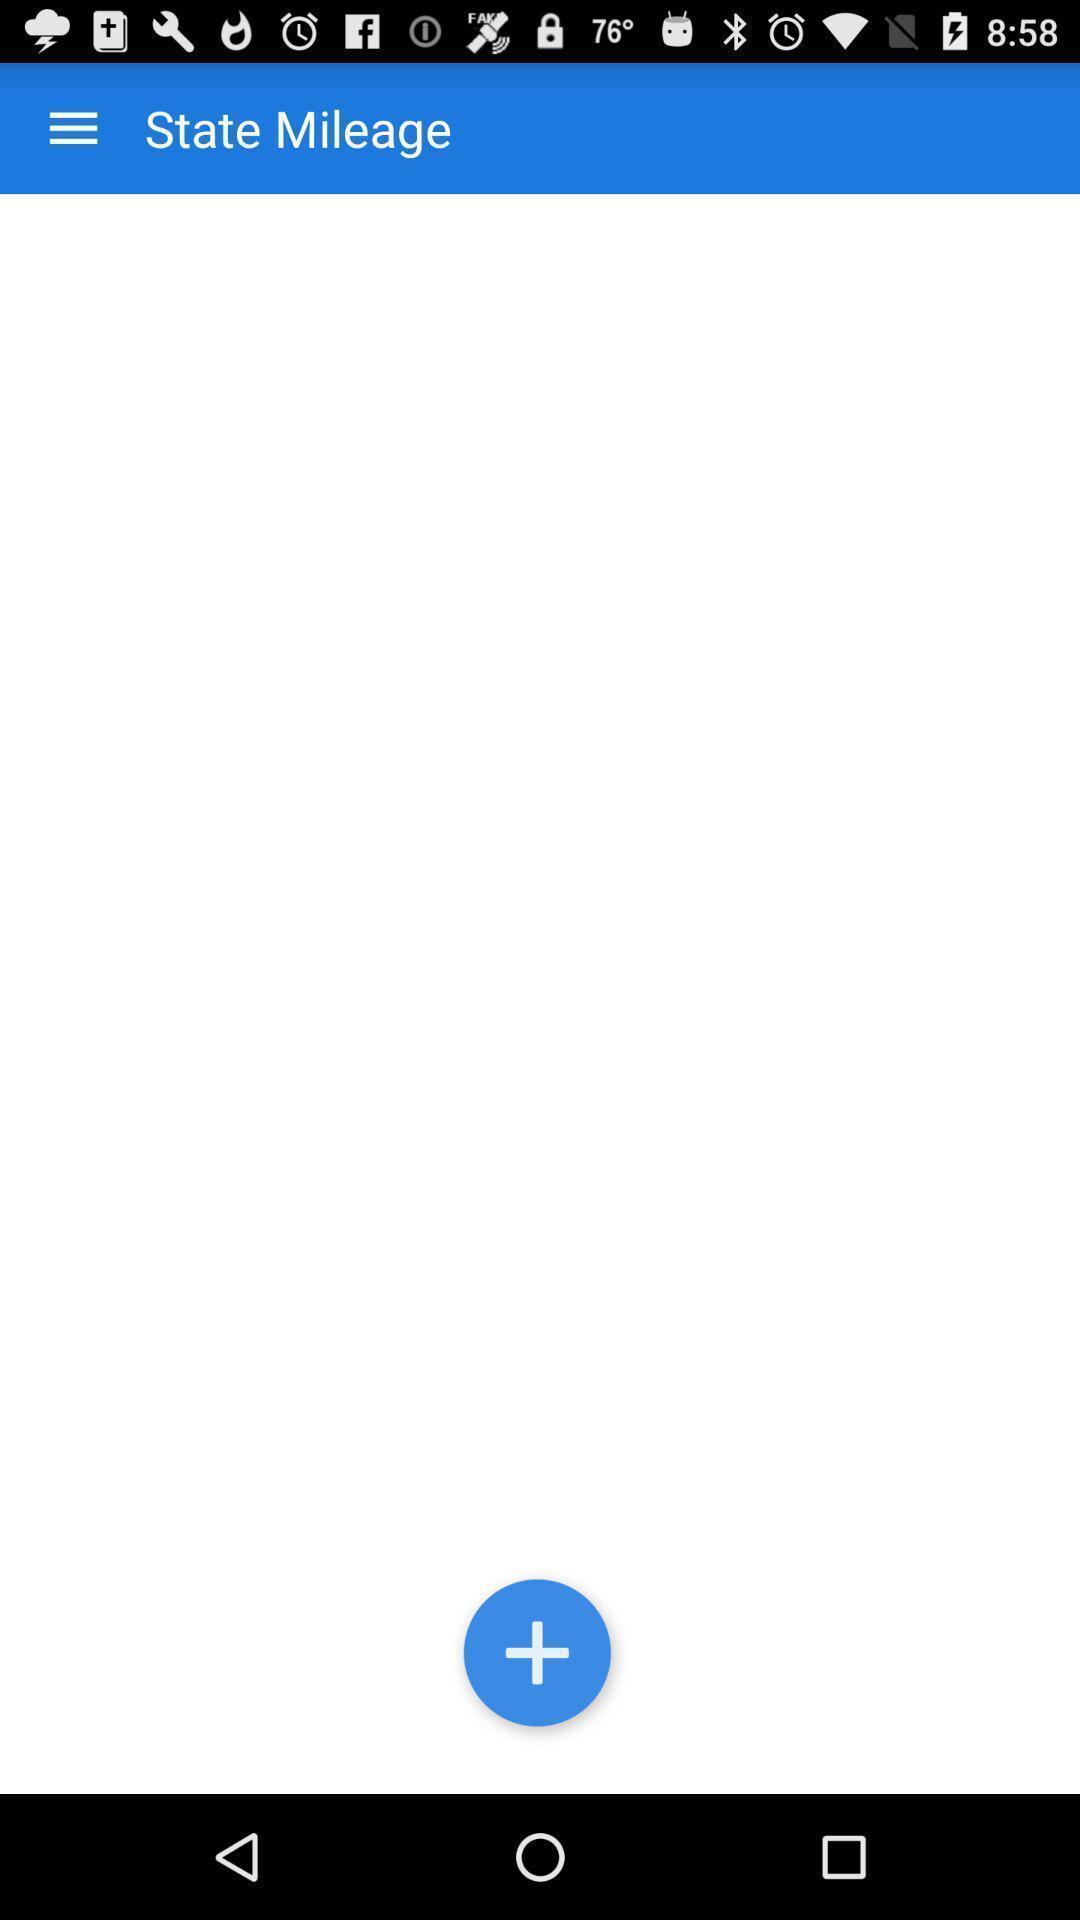Provide a description of this screenshot. Page displaying to add mileages in app. 